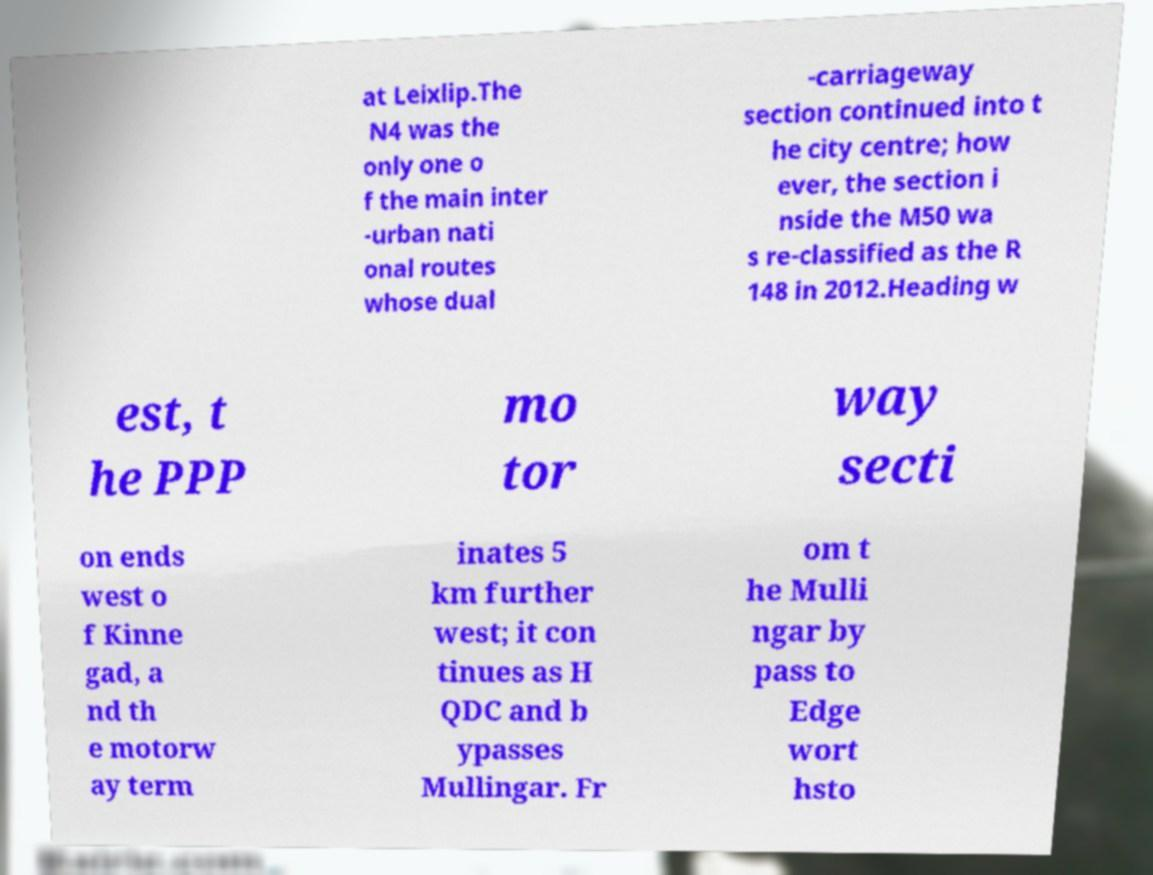Please read and relay the text visible in this image. What does it say? at Leixlip.The N4 was the only one o f the main inter -urban nati onal routes whose dual -carriageway section continued into t he city centre; how ever, the section i nside the M50 wa s re-classified as the R 148 in 2012.Heading w est, t he PPP mo tor way secti on ends west o f Kinne gad, a nd th e motorw ay term inates 5 km further west; it con tinues as H QDC and b ypasses Mullingar. Fr om t he Mulli ngar by pass to Edge wort hsto 